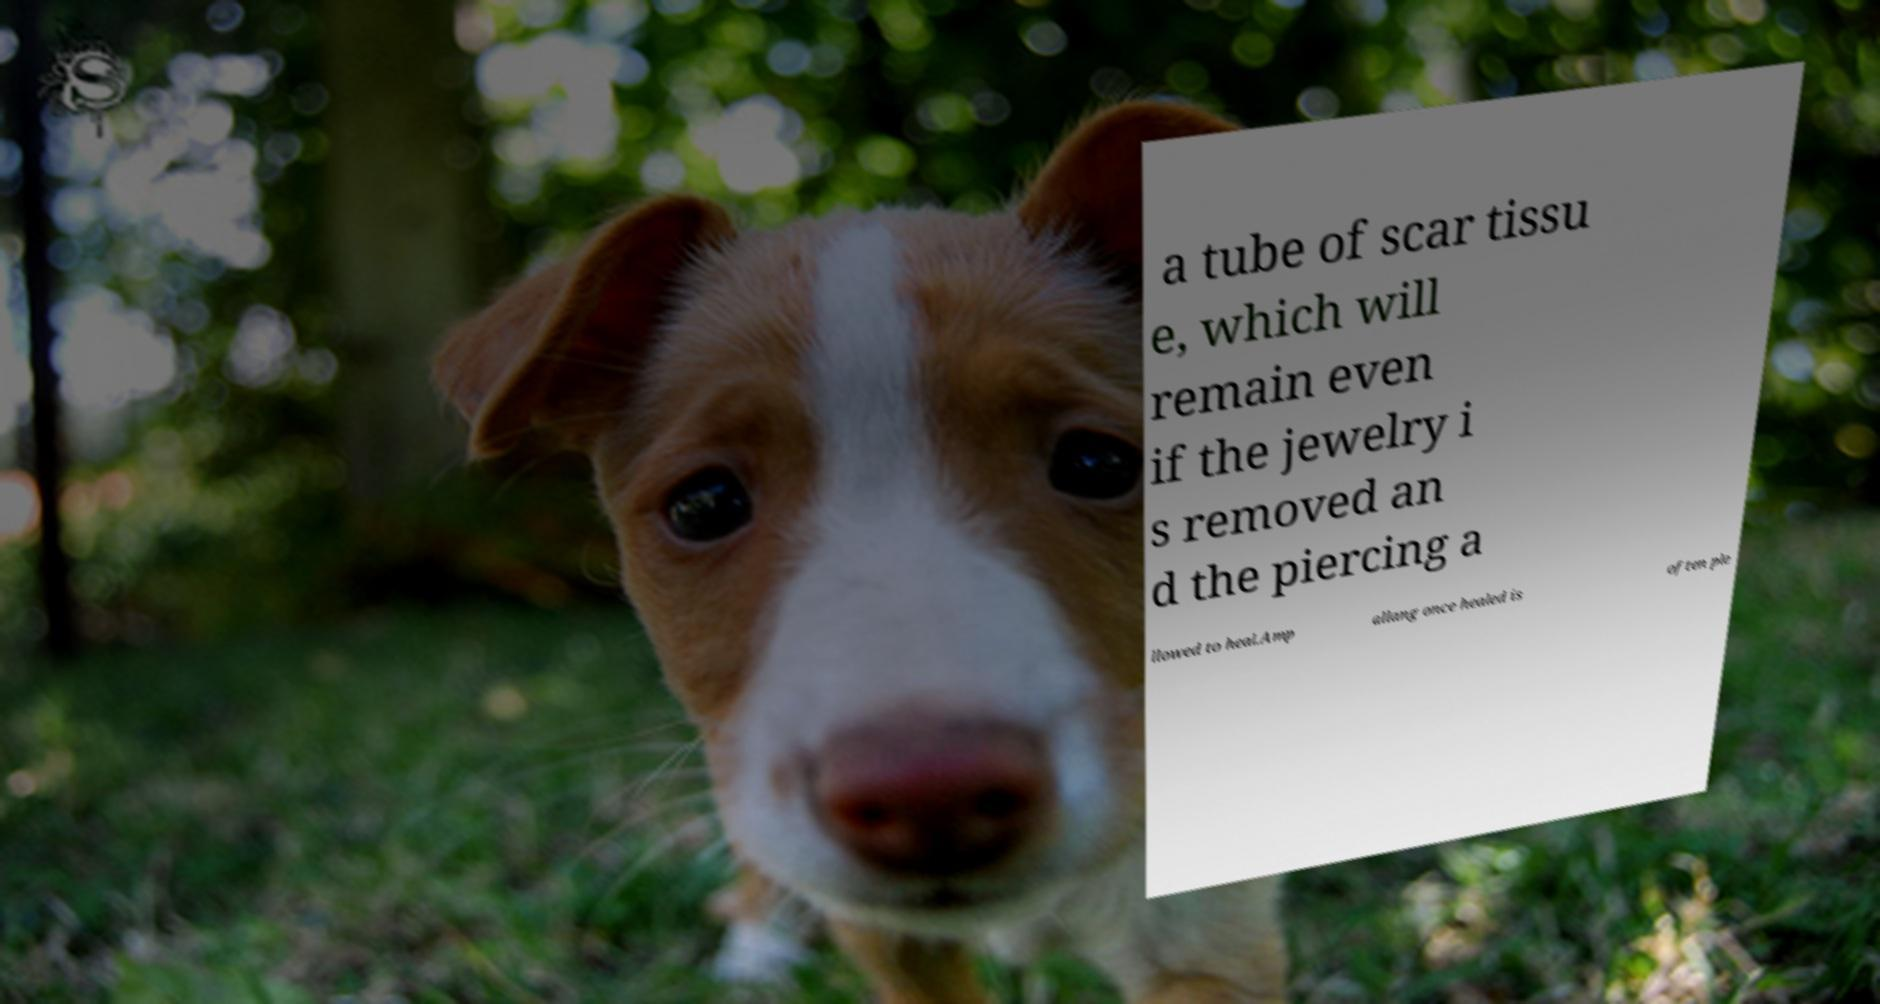What messages or text are displayed in this image? I need them in a readable, typed format. a tube of scar tissu e, which will remain even if the jewelry i s removed an d the piercing a llowed to heal.Amp allang once healed is often ple 